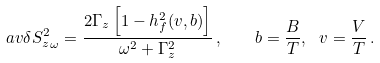<formula> <loc_0><loc_0><loc_500><loc_500>\ a v { \delta S _ { z } ^ { 2 } } _ { \omega } = \frac { 2 \Gamma _ { z } \left [ 1 - h _ { f } ^ { 2 } ( v , b ) \right ] } { \omega ^ { 2 } + \Gamma _ { z } ^ { 2 } } \, , \quad b = \frac { B } { T } , \ v = \frac { V } { T } \, .</formula> 